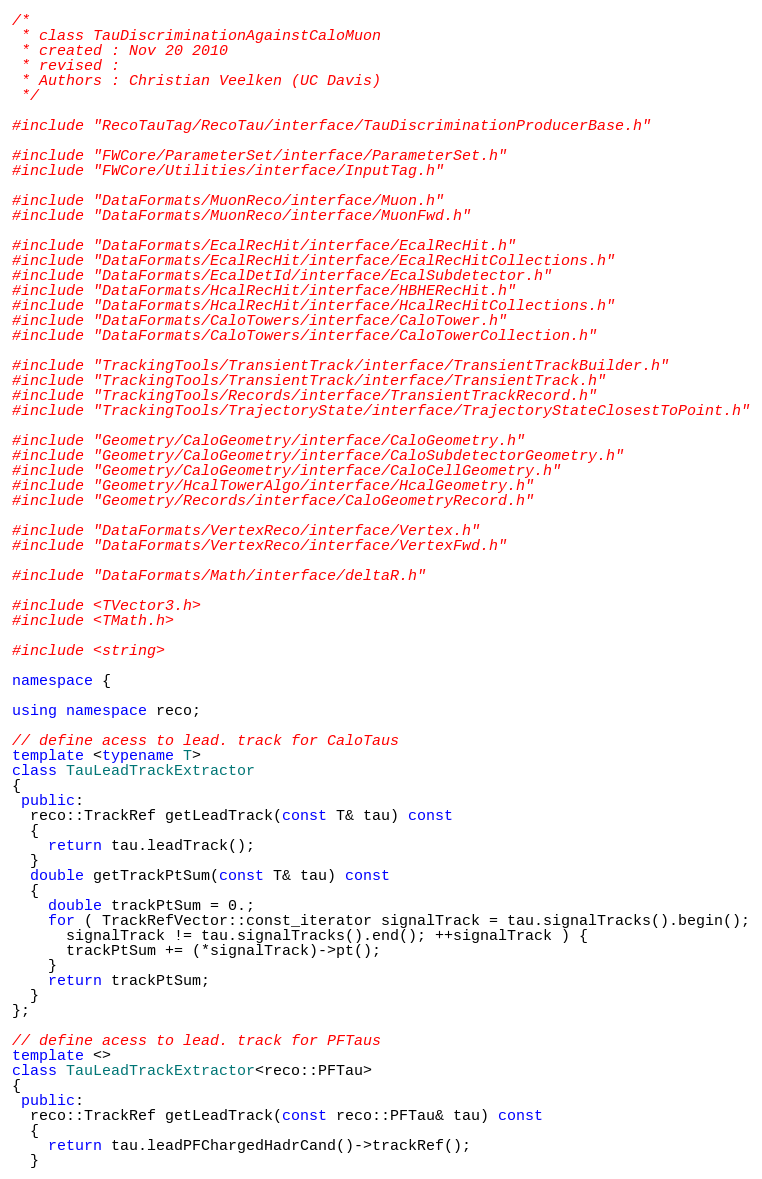Convert code to text. <code><loc_0><loc_0><loc_500><loc_500><_C++_>
/* 
 * class TauDiscriminationAgainstCaloMuon
 * created : Nov 20 2010
 * revised : 
 * Authors : Christian Veelken (UC Davis)
 */

#include "RecoTauTag/RecoTau/interface/TauDiscriminationProducerBase.h"

#include "FWCore/ParameterSet/interface/ParameterSet.h"
#include "FWCore/Utilities/interface/InputTag.h"

#include "DataFormats/MuonReco/interface/Muon.h"
#include "DataFormats/MuonReco/interface/MuonFwd.h"

#include "DataFormats/EcalRecHit/interface/EcalRecHit.h"
#include "DataFormats/EcalRecHit/interface/EcalRecHitCollections.h"
#include "DataFormats/EcalDetId/interface/EcalSubdetector.h"
#include "DataFormats/HcalRecHit/interface/HBHERecHit.h"
#include "DataFormats/HcalRecHit/interface/HcalRecHitCollections.h"
#include "DataFormats/CaloTowers/interface/CaloTower.h"
#include "DataFormats/CaloTowers/interface/CaloTowerCollection.h"

#include "TrackingTools/TransientTrack/interface/TransientTrackBuilder.h"
#include "TrackingTools/TransientTrack/interface/TransientTrack.h"
#include "TrackingTools/Records/interface/TransientTrackRecord.h"
#include "TrackingTools/TrajectoryState/interface/TrajectoryStateClosestToPoint.h"

#include "Geometry/CaloGeometry/interface/CaloGeometry.h"
#include "Geometry/CaloGeometry/interface/CaloSubdetectorGeometry.h"
#include "Geometry/CaloGeometry/interface/CaloCellGeometry.h"
#include "Geometry/HcalTowerAlgo/interface/HcalGeometry.h"
#include "Geometry/Records/interface/CaloGeometryRecord.h"

#include "DataFormats/VertexReco/interface/Vertex.h"
#include "DataFormats/VertexReco/interface/VertexFwd.h"

#include "DataFormats/Math/interface/deltaR.h"

#include <TVector3.h>
#include <TMath.h>

#include <string>

namespace {

using namespace reco;

// define acess to lead. track for CaloTaus
template <typename T>
class TauLeadTrackExtractor
{
 public:
  reco::TrackRef getLeadTrack(const T& tau) const
  {
    return tau.leadTrack();
  }
  double getTrackPtSum(const T& tau) const
  {
    double trackPtSum = 0.;
    for ( TrackRefVector::const_iterator signalTrack = tau.signalTracks().begin();
	  signalTrack != tau.signalTracks().end(); ++signalTrack ) {
      trackPtSum += (*signalTrack)->pt();
    }
    return trackPtSum;
  }
};

// define acess to lead. track for PFTaus
template <>
class TauLeadTrackExtractor<reco::PFTau>
{
 public:
  reco::TrackRef getLeadTrack(const reco::PFTau& tau) const
  {
    return tau.leadPFChargedHadrCand()->trackRef();
  }</code> 